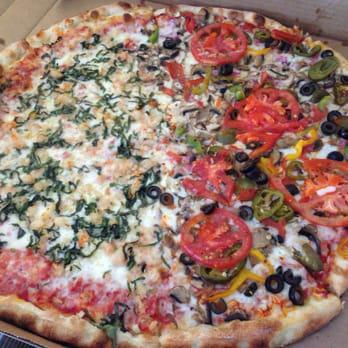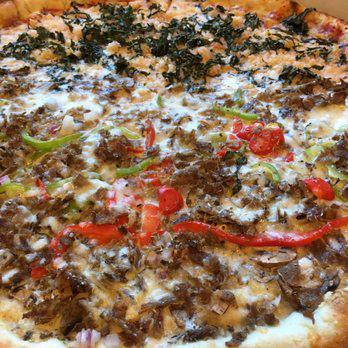The first image is the image on the left, the second image is the image on the right. For the images shown, is this caption "One image shows a whole pizza with black olives and red pepper strips on top, and the other image shows no more than two wedge-shaped slices on something made of paper." true? Answer yes or no. No. The first image is the image on the left, the second image is the image on the right. Considering the images on both sides, is "There are two whole pizzas ready to eat." valid? Answer yes or no. Yes. 